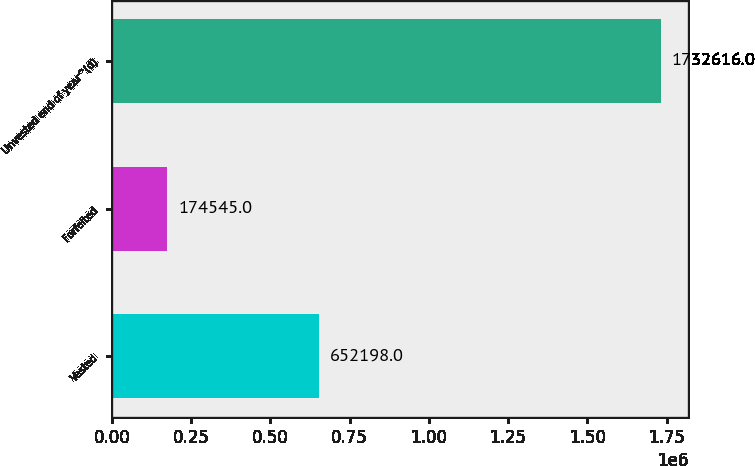Convert chart to OTSL. <chart><loc_0><loc_0><loc_500><loc_500><bar_chart><fcel>Vested<fcel>Forfeited<fcel>Unvested end of year^(d)<nl><fcel>652198<fcel>174545<fcel>1.73262e+06<nl></chart> 